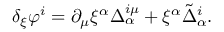<formula> <loc_0><loc_0><loc_500><loc_500>\delta _ { \xi } \varphi ^ { i } = \partial _ { \mu } \xi ^ { \alpha } \Delta _ { \alpha } ^ { i \mu } + \xi ^ { \alpha } \tilde { \Delta } _ { \alpha } ^ { i } .</formula> 